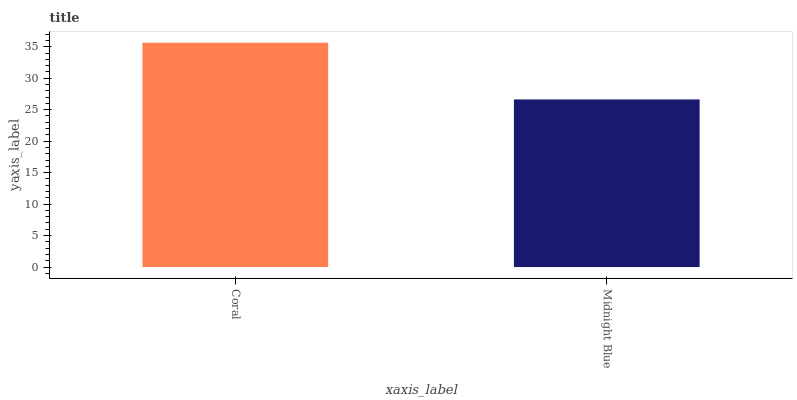Is Midnight Blue the minimum?
Answer yes or no. Yes. Is Coral the maximum?
Answer yes or no. Yes. Is Midnight Blue the maximum?
Answer yes or no. No. Is Coral greater than Midnight Blue?
Answer yes or no. Yes. Is Midnight Blue less than Coral?
Answer yes or no. Yes. Is Midnight Blue greater than Coral?
Answer yes or no. No. Is Coral less than Midnight Blue?
Answer yes or no. No. Is Coral the high median?
Answer yes or no. Yes. Is Midnight Blue the low median?
Answer yes or no. Yes. Is Midnight Blue the high median?
Answer yes or no. No. Is Coral the low median?
Answer yes or no. No. 